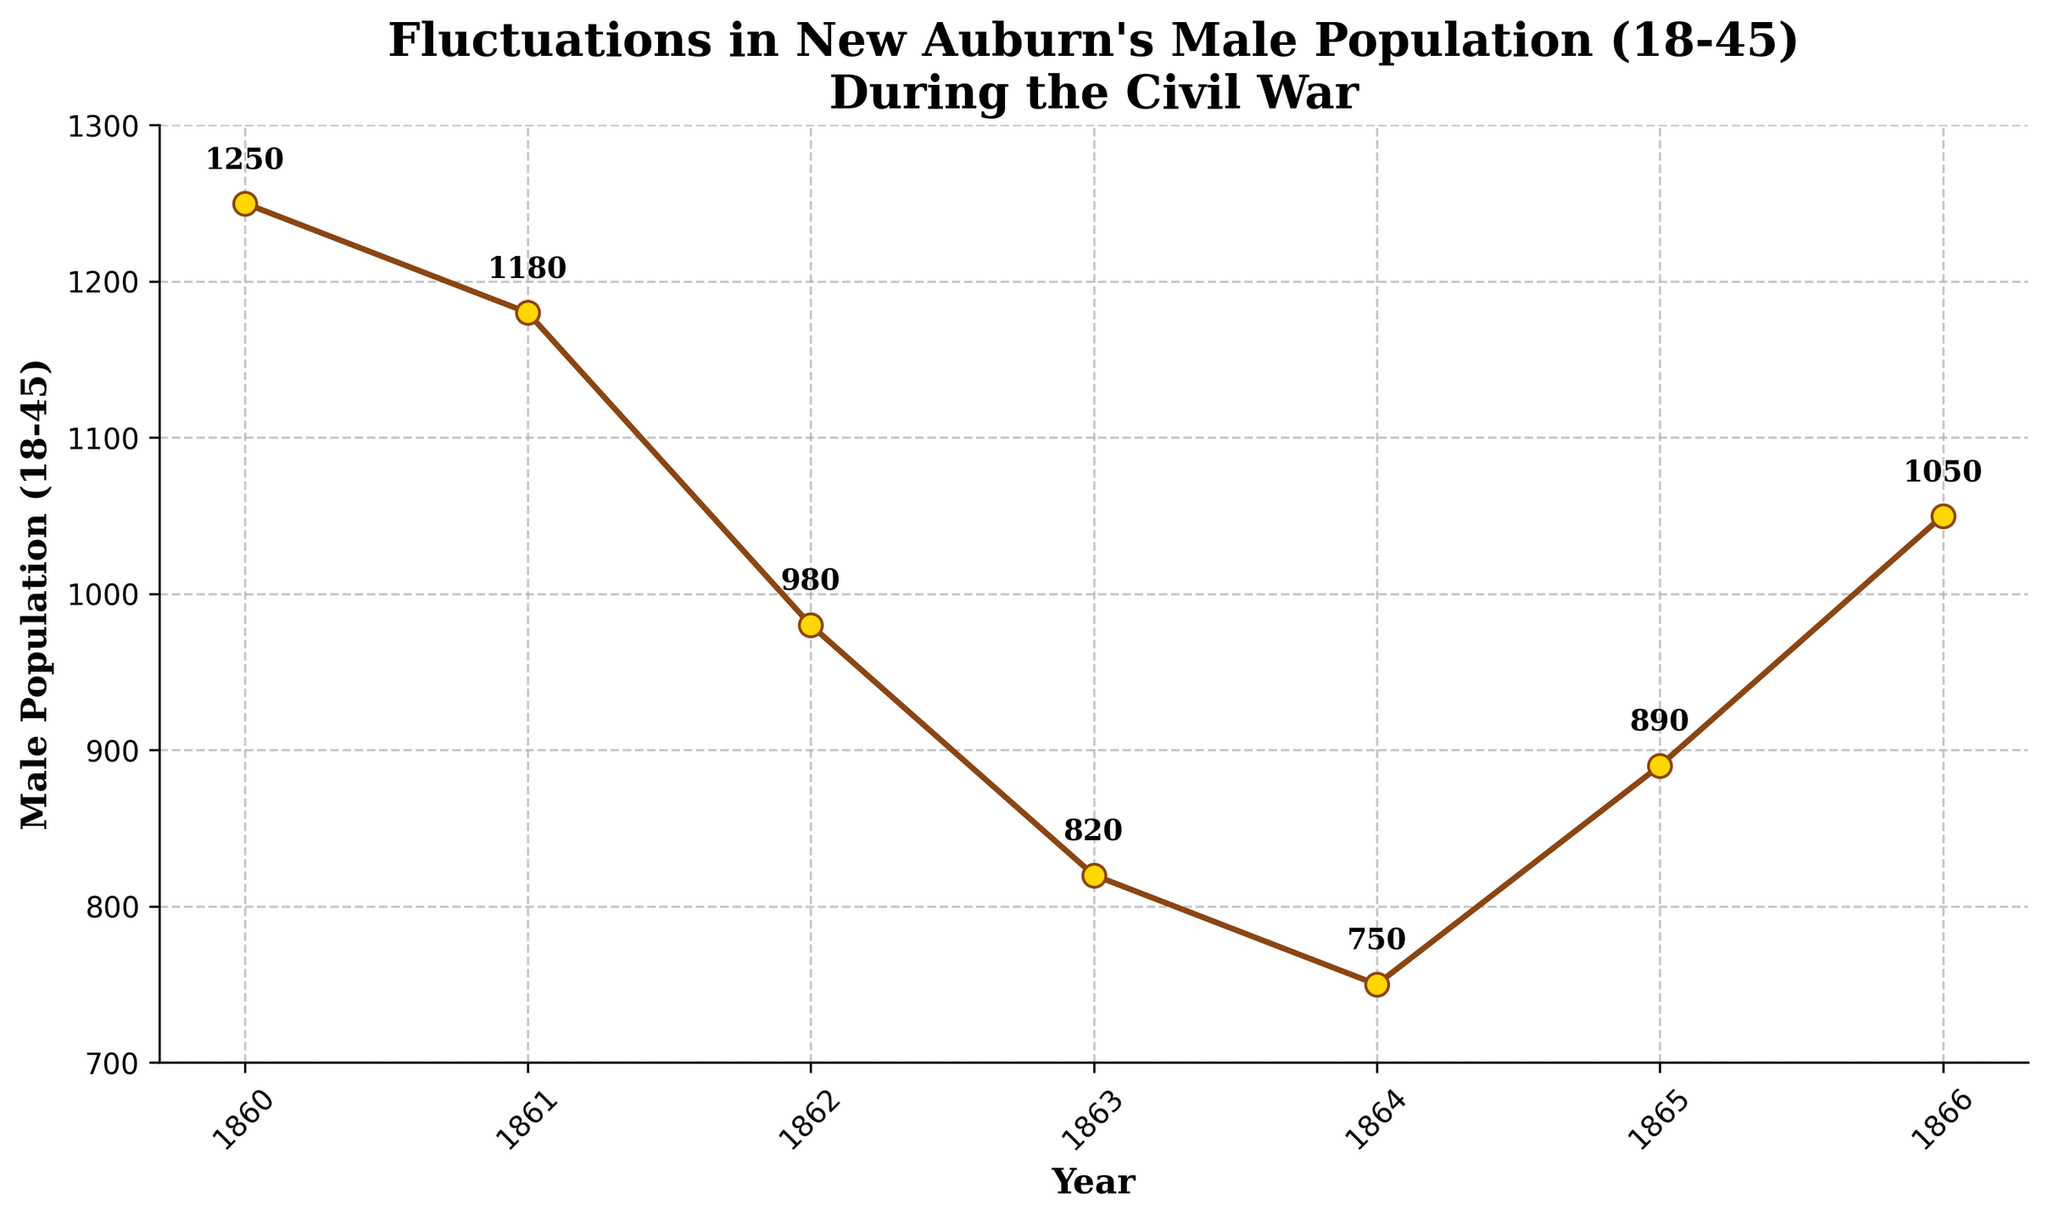What was the male population (18-45) in New Auburn at the start and end of the Civil War? Look at the population values for the years 1861 and 1865. They are 1180 and 890 respectively.
Answer: 1180 and 890 In which year did the male population (18-45) reach its lowest point? Refer to the plotted points and find the year where the population figure appears the lowest. It is 1864, with a population of 750.
Answer: 1864 What was the difference in the male population (18-45) between 1860 and 1862? Subtract the population value of 1862 from that of 1860: 1250 - 980 = 270.
Answer: 270 How did the male population (18-45) change from 1865 to 1866? Observe the plot: the population increased from 890 in 1865 to 1050 in 1866. Calculate the change by subtracting: 1050 - 890 = 160.
Answer: Increased by 160 Which year experienced the greatest drop in the male population (18-45) from the year before? Calculate the difference for each consecutive year: 
1861-1860 = 70, 1862-1861 = 200, 1863-1862 = 160, 1864-1863 = 70, and 1865-1864 = -140; the greatest drop is from 1861 to 1862.
Answer: 1862 How many times did the male population (18-45) increase from one year to the next during the Civil War period (1861-1865)? Check the population values year-over-year for any increases. From 1861 to 1865, the population never increased; it decreased every year.
Answer: 0 What was the average male population (18-45) in New Auburn during the Civil War years (1861-1865)? Add the population values for each year and divide by the number of years: (1180 + 980 + 820 + 750 + 890)/5 = 924.
Answer: 924 Was the male population (18-45) higher in 1860 or 1866? Compare the population values for 1860 and 1866: 1250 in 1860 is higher than 1050 in 1866.
Answer: 1860 By how much did the male population (18-45) decrease from 1860 to 1863? Subtract the population value in 1863 from that in 1860: 1250 - 820 = 430.
Answer: 430 How many years did it take for the male population (18-45) to return to above 1000 after dropping below it during the Civil War period? The population fell below 1000 in 1862 (980) and returned above 1000 in 1866 (1050). So, it took 4 years.
Answer: 4 